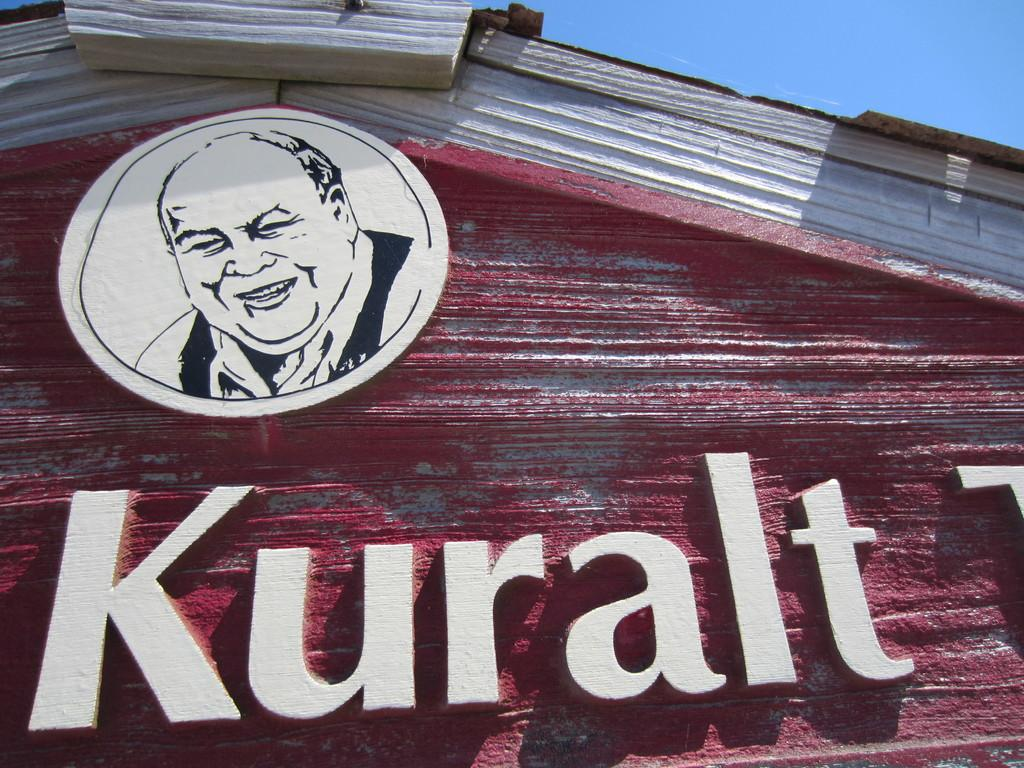Who or what is present in the image? There is a person in the image. What is the person doing or standing on? The person is on a board. What else can be seen in the image besides the person? There is a name board and a wall in the image. What is visible behind the wall? The sky is visible behind the wall. How much money is being exchanged between the person and the wall in the image? There is no money exchange depicted in the image. The person is on a board, and there is a name board and a wall present, but no financial transaction is taking place. 